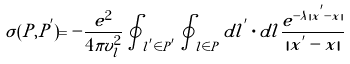Convert formula to latex. <formula><loc_0><loc_0><loc_500><loc_500>\sigma ( P , P ^ { ^ { \prime } } ) = - \frac { e ^ { 2 } } { 4 \pi v ^ { 2 } _ { l } } \oint _ { { l } ^ { ^ { \prime } } \in P ^ { ^ { \prime } } } \oint _ { { l } \in P } d { l } ^ { ^ { \prime } } \cdot d { l } \frac { e ^ { - \lambda | { x } ^ { ^ { \prime } } - { x } | } } { | { x } ^ { ^ { \prime } } - { x } | }</formula> 